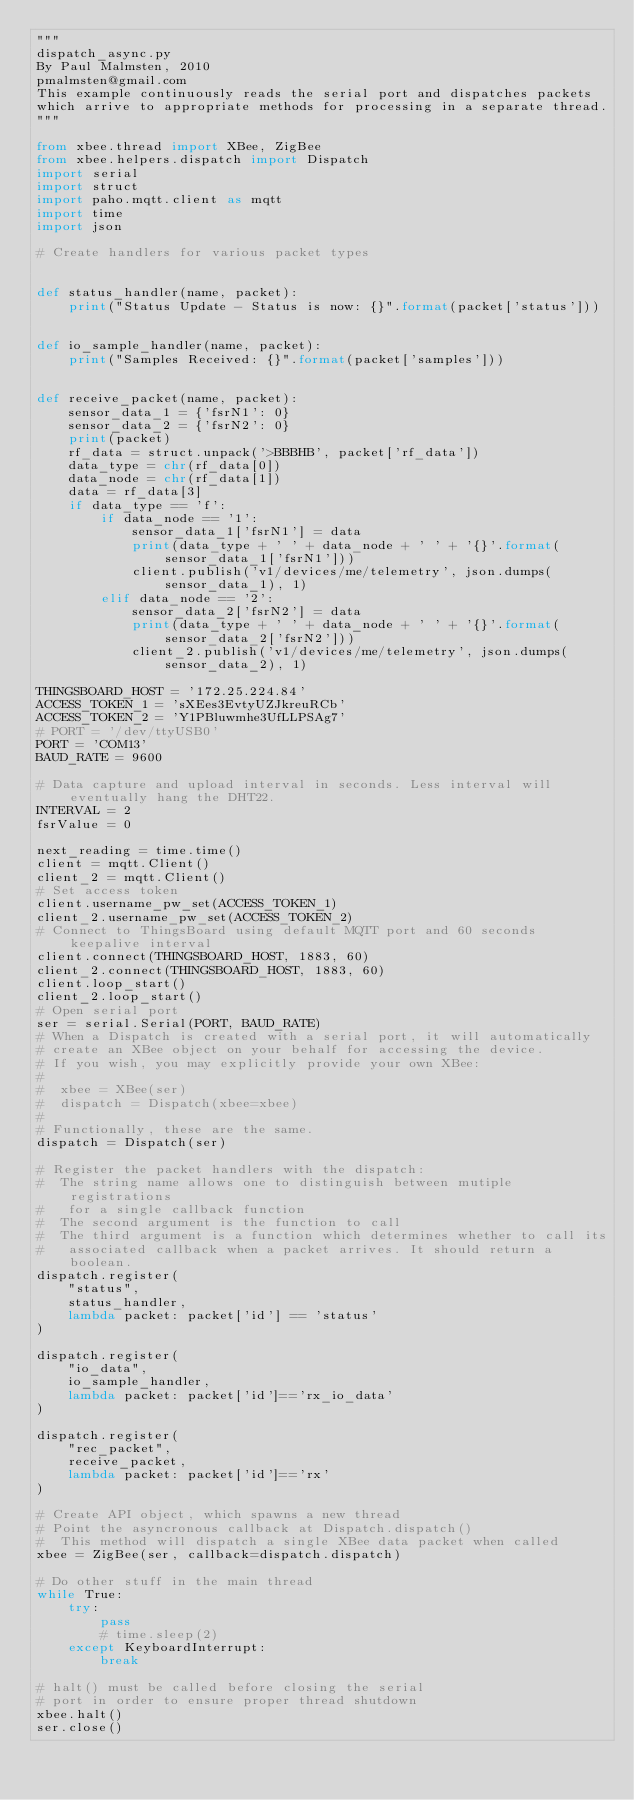Convert code to text. <code><loc_0><loc_0><loc_500><loc_500><_Python_>"""
dispatch_async.py
By Paul Malmsten, 2010
pmalmsten@gmail.com
This example continuously reads the serial port and dispatches packets
which arrive to appropriate methods for processing in a separate thread.
"""

from xbee.thread import XBee, ZigBee
from xbee.helpers.dispatch import Dispatch
import serial
import struct
import paho.mqtt.client as mqtt
import time
import json

# Create handlers for various packet types


def status_handler(name, packet):
    print("Status Update - Status is now: {}".format(packet['status']))


def io_sample_handler(name, packet):
    print("Samples Received: {}".format(packet['samples']))


def receive_packet(name, packet):
    sensor_data_1 = {'fsrN1': 0}
    sensor_data_2 = {'fsrN2': 0}
    print(packet)
    rf_data = struct.unpack('>BBBHB', packet['rf_data'])
    data_type = chr(rf_data[0])
    data_node = chr(rf_data[1])
    data = rf_data[3]
    if data_type == 'f':
        if data_node == '1':
            sensor_data_1['fsrN1'] = data
            print(data_type + ' ' + data_node + ' ' + '{}'.format(sensor_data_1['fsrN1']))
            client.publish('v1/devices/me/telemetry', json.dumps(sensor_data_1), 1)
        elif data_node == '2':
            sensor_data_2['fsrN2'] = data
            print(data_type + ' ' + data_node + ' ' + '{}'.format(sensor_data_2['fsrN2']))
            client_2.publish('v1/devices/me/telemetry', json.dumps(sensor_data_2), 1)

THINGSBOARD_HOST = '172.25.224.84'
ACCESS_TOKEN_1 = 'sXEes3EvtyUZJkreuRCb'
ACCESS_TOKEN_2 = 'Y1PBluwmhe3UfLLPSAg7'
# PORT = '/dev/ttyUSB0'
PORT = 'COM13'
BAUD_RATE = 9600

# Data capture and upload interval in seconds. Less interval will eventually hang the DHT22.
INTERVAL = 2
fsrValue = 0

next_reading = time.time()
client = mqtt.Client()
client_2 = mqtt.Client()
# Set access token
client.username_pw_set(ACCESS_TOKEN_1)
client_2.username_pw_set(ACCESS_TOKEN_2)
# Connect to ThingsBoard using default MQTT port and 60 seconds keepalive interval
client.connect(THINGSBOARD_HOST, 1883, 60)
client_2.connect(THINGSBOARD_HOST, 1883, 60)
client.loop_start()
client_2.loop_start()
# Open serial port
ser = serial.Serial(PORT, BAUD_RATE)
# When a Dispatch is created with a serial port, it will automatically
# create an XBee object on your behalf for accessing the device.
# If you wish, you may explicitly provide your own XBee:
#
#  xbee = XBee(ser)
#  dispatch = Dispatch(xbee=xbee)
#
# Functionally, these are the same.
dispatch = Dispatch(ser)

# Register the packet handlers with the dispatch:
#  The string name allows one to distinguish between mutiple registrations
#   for a single callback function
#  The second argument is the function to call
#  The third argument is a function which determines whether to call its
#   associated callback when a packet arrives. It should return a boolean.
dispatch.register(
    "status",
    status_handler,
    lambda packet: packet['id'] == 'status'
)

dispatch.register(
    "io_data",
    io_sample_handler,
    lambda packet: packet['id']=='rx_io_data'
)

dispatch.register(
    "rec_packet",
    receive_packet,
    lambda packet: packet['id']=='rx'
)

# Create API object, which spawns a new thread
# Point the asyncronous callback at Dispatch.dispatch()
#  This method will dispatch a single XBee data packet when called
xbee = ZigBee(ser, callback=dispatch.dispatch)

# Do other stuff in the main thread
while True:
    try:
        pass
        # time.sleep(2)
    except KeyboardInterrupt:
        break

# halt() must be called before closing the serial
# port in order to ensure proper thread shutdown
xbee.halt()
ser.close()
</code> 